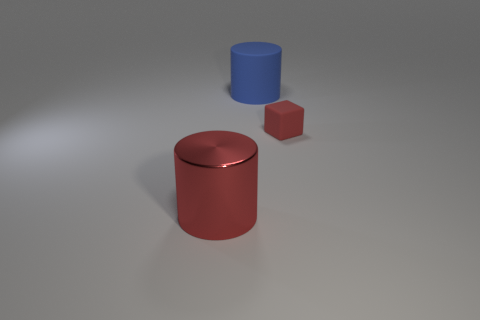Add 1 cubes. How many objects exist? 4 Subtract all cylinders. How many objects are left? 1 Add 3 tiny red things. How many tiny red things are left? 4 Add 3 red metallic cylinders. How many red metallic cylinders exist? 4 Subtract 1 red blocks. How many objects are left? 2 Subtract all tiny cyan rubber blocks. Subtract all large things. How many objects are left? 1 